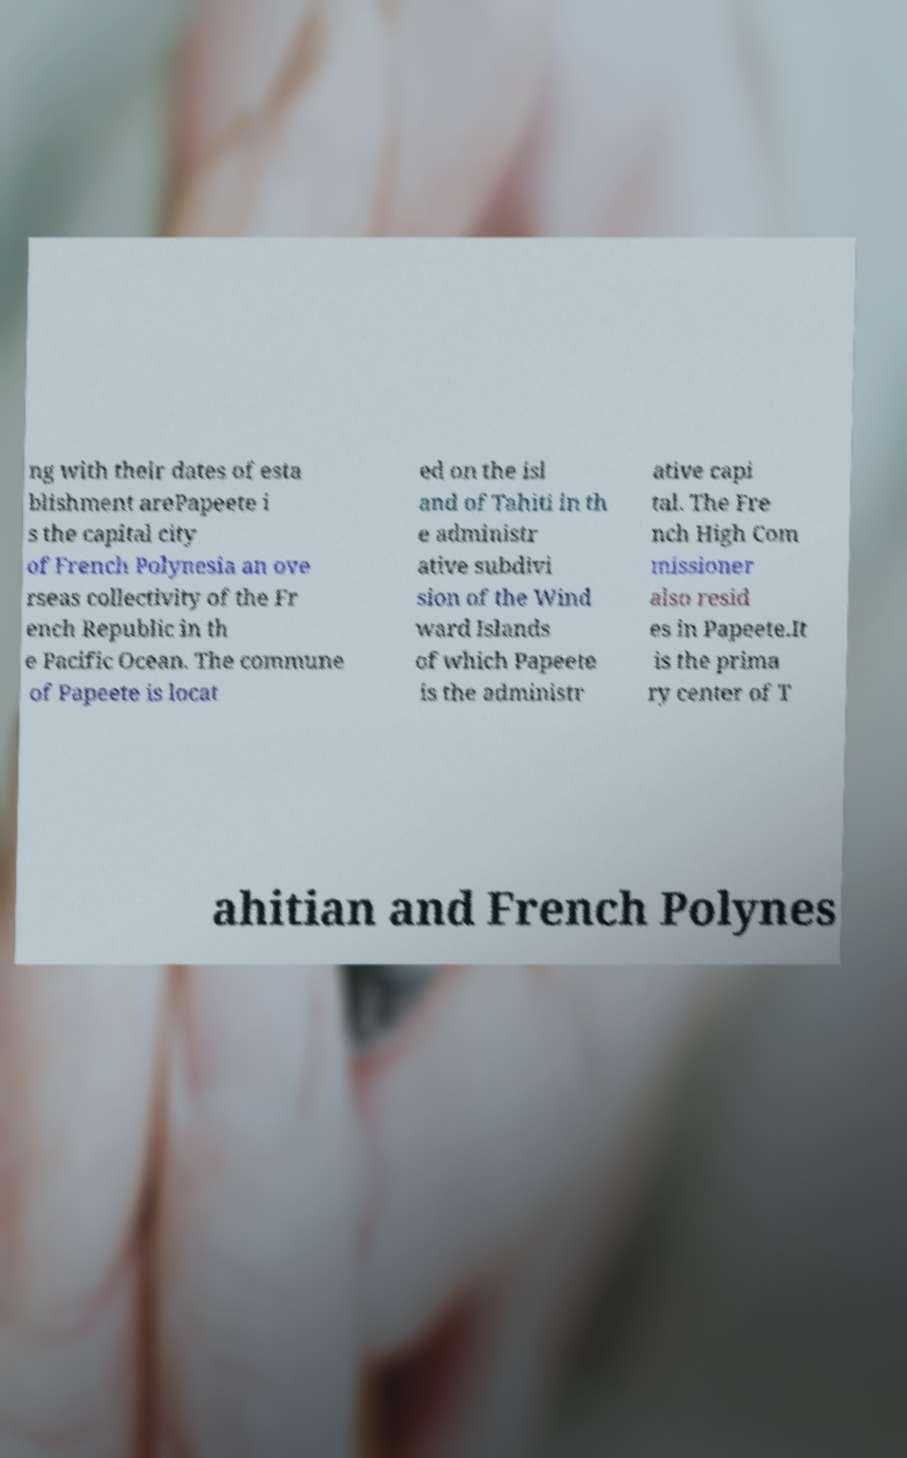I need the written content from this picture converted into text. Can you do that? ng with their dates of esta blishment arePapeete i s the capital city of French Polynesia an ove rseas collectivity of the Fr ench Republic in th e Pacific Ocean. The commune of Papeete is locat ed on the isl and of Tahiti in th e administr ative subdivi sion of the Wind ward Islands of which Papeete is the administr ative capi tal. The Fre nch High Com missioner also resid es in Papeete.It is the prima ry center of T ahitian and French Polynes 